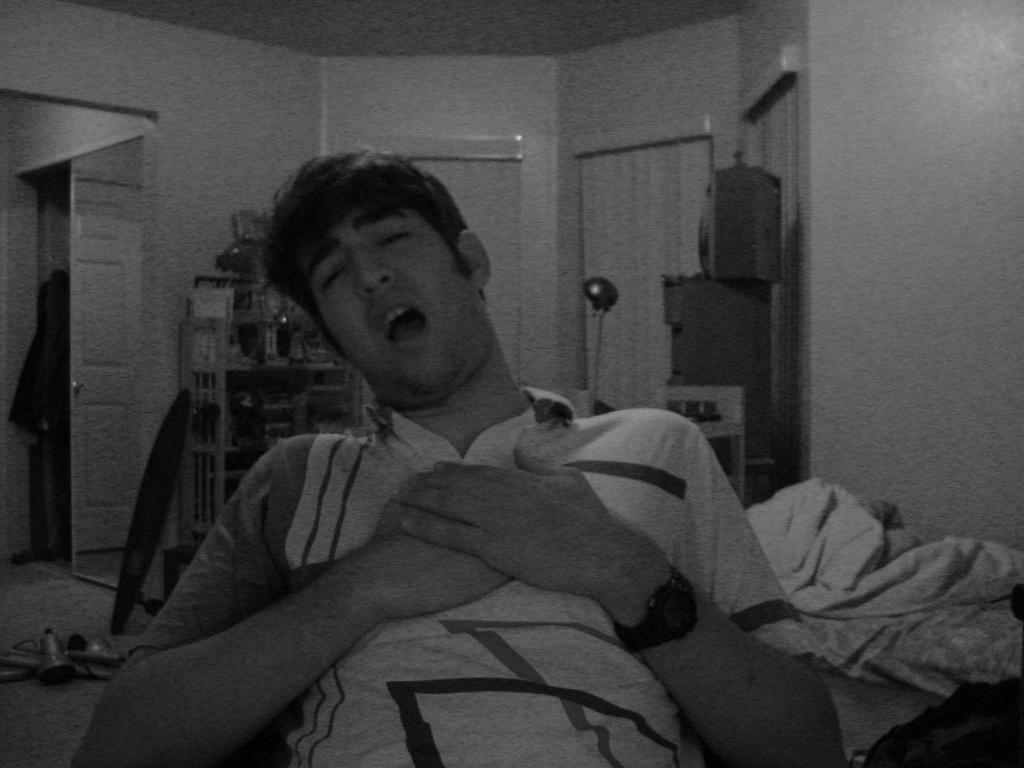Describe this image in one or two sentences. In this image we can see a black and white image. In this image we can see a person. In the background of the image there is a wall, curtains, door and other objects. 